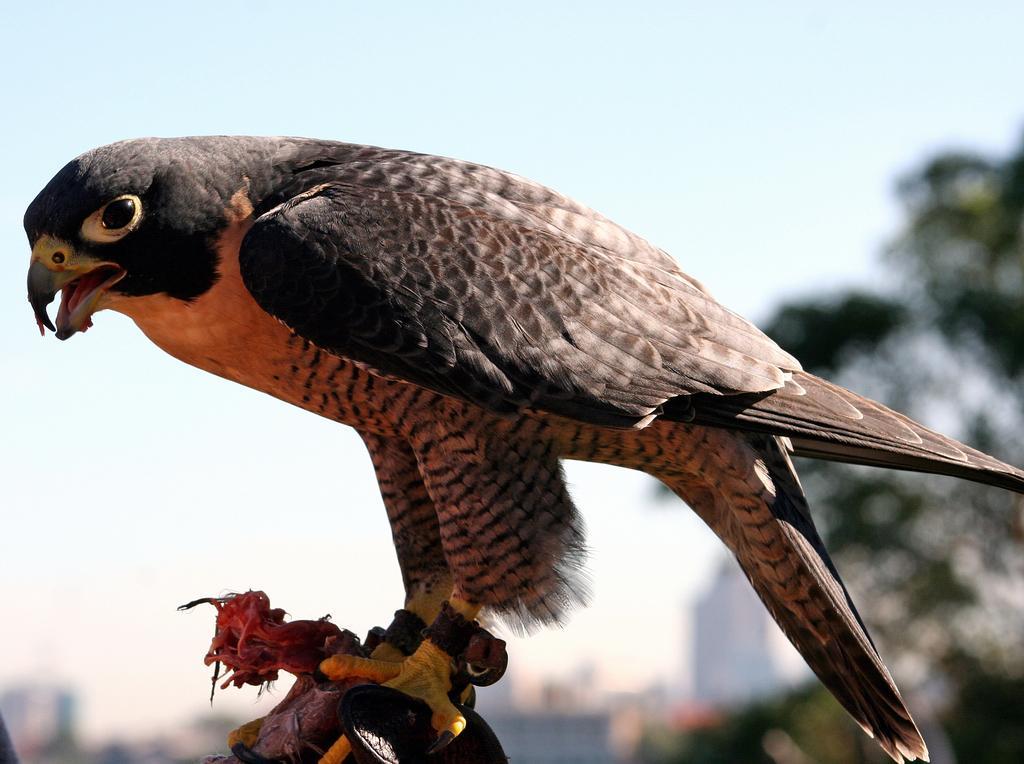Describe this image in one or two sentences. In this image, this looks like an eagle bird standing. The background looks blurry. 